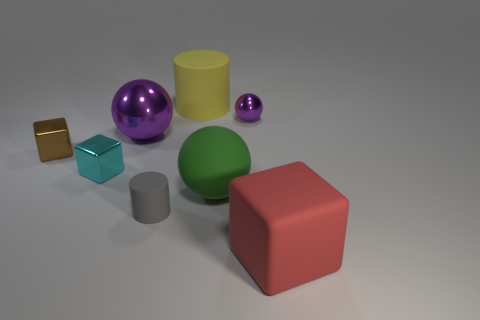There is a cyan metal thing; does it have the same size as the metal ball left of the small metal ball?
Offer a very short reply. No. How many other objects are there of the same color as the big metal object?
Offer a very short reply. 1. There is a red thing; are there any red objects behind it?
Your answer should be very brief. No. How many objects are either gray metal cubes or purple balls in front of the small purple shiny ball?
Offer a very short reply. 1. Is there a green object on the left side of the cylinder behind the large green rubber object?
Keep it short and to the point. No. There is a purple thing left of the rubber cylinder that is behind the purple metal ball right of the big purple shiny thing; what is its shape?
Your answer should be compact. Sphere. There is a big matte thing that is both behind the small cylinder and in front of the big yellow matte cylinder; what is its color?
Offer a terse response. Green. There is a shiny thing behind the big purple object; what shape is it?
Give a very brief answer. Sphere. What shape is the big yellow object that is made of the same material as the small cylinder?
Make the answer very short. Cylinder. What number of matte objects are either small cylinders or large red things?
Keep it short and to the point. 2. 